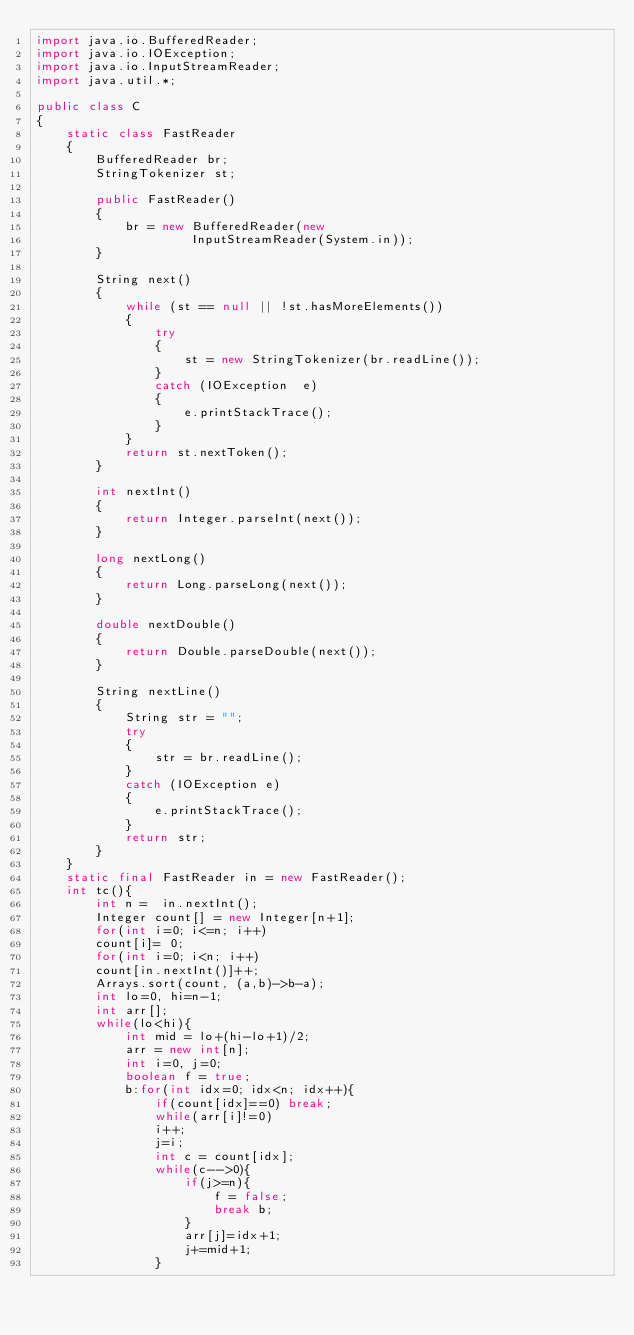Convert code to text. <code><loc_0><loc_0><loc_500><loc_500><_Java_>import java.io.BufferedReader; 
import java.io.IOException; 
import java.io.InputStreamReader; 
import java.util.*; 
  
public class C 
{ 
    static class FastReader 
    { 
        BufferedReader br; 
        StringTokenizer st; 
  
        public FastReader() 
        { 
            br = new BufferedReader(new
                     InputStreamReader(System.in)); 
        } 
  
        String next() 
        { 
            while (st == null || !st.hasMoreElements()) 
            { 
                try
                { 
                    st = new StringTokenizer(br.readLine()); 
                } 
                catch (IOException  e) 
                { 
                    e.printStackTrace(); 
                } 
            } 
            return st.nextToken(); 
        } 
  
        int nextInt() 
        { 
            return Integer.parseInt(next()); 
        } 
  
        long nextLong() 
        { 
            return Long.parseLong(next()); 
        } 
  
        double nextDouble() 
        { 
            return Double.parseDouble(next()); 
        } 
  
        String nextLine() 
        { 
            String str = ""; 
            try
            { 
                str = br.readLine(); 
            } 
            catch (IOException e) 
            { 
                e.printStackTrace(); 
            } 
            return str; 
        } 
    } 
    static final FastReader in = new FastReader();
    int tc(){
        int n =  in.nextInt();
        Integer count[] = new Integer[n+1];
        for(int i=0; i<=n; i++)
        count[i]= 0;
        for(int i=0; i<n; i++)
        count[in.nextInt()]++;
        Arrays.sort(count, (a,b)->b-a);
        int lo=0, hi=n-1;
        int arr[];
        while(lo<hi){
            int mid = lo+(hi-lo+1)/2;
            arr = new int[n];
            int i=0, j=0;
            boolean f = true;
            b:for(int idx=0; idx<n; idx++){
                if(count[idx]==0) break;
                while(arr[i]!=0)
                i++;
                j=i;
                int c = count[idx];
                while(c-->0){
                    if(j>=n){
                        f = false;
                        break b;
                    }
                    arr[j]=idx+1;
                    j+=mid+1;
                }</code> 